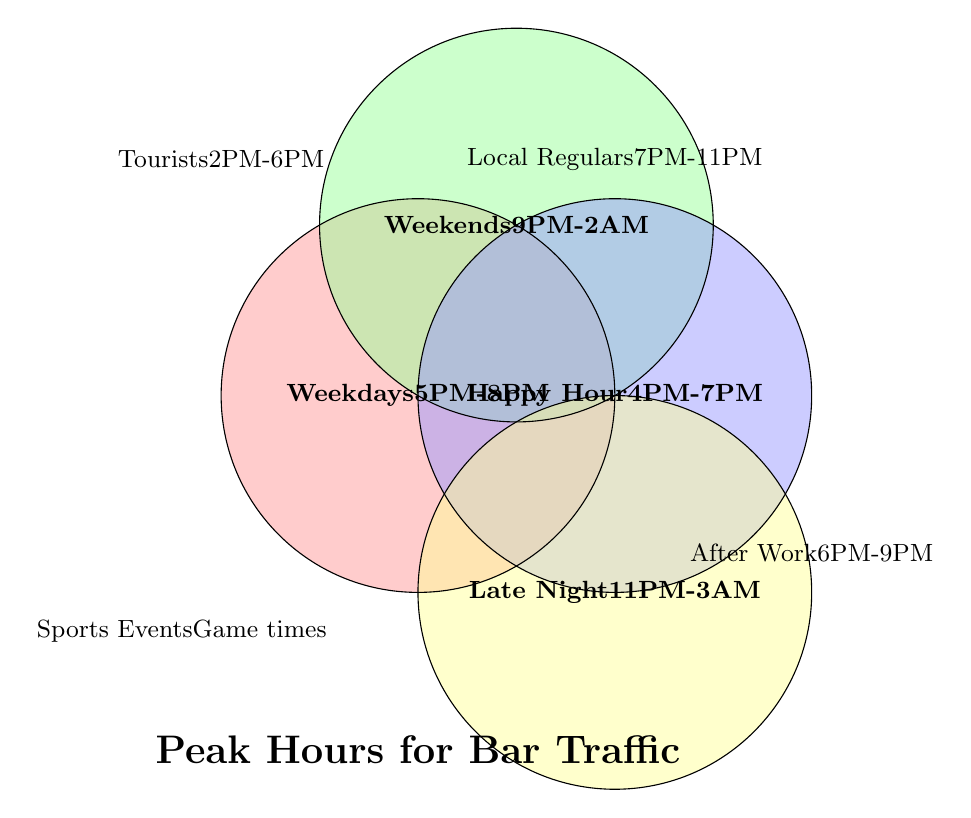What is the peak hour range for Weekdays? Locate the section labeled "Weekdays" in the Venn Diagram, which shows "5PM-8PM."
Answer: 5PM-8PM When do Tourists tend to visit the bar most frequently? Find the block labeled "Tourists," which shows "2PM-6PM."
Answer: 2PM-6PM Which group has a peak hour range overlapping with Happy Hour? Compare "Happy Hour" (4PM-7PM) with other groups. The After Work Crowd overlaps (6PM-9PM).
Answer: After Work Crowd What are the peak hours for the After Work Crowd? Find the block labeled "After Work Crowd," which shows "6PM-9PM."
Answer: 6PM-9PM Are the peak hours for Local Regulars completely within Late Night hours? Compare "Local Regulars" (7PM-11PM) with "Late Night" (11PM-3AM). The hours do not overlap completely; Local Regulars peak before Late Night starts.
Answer: No Which group has the latest peak hours? Identify the group with the latest ending time, "Late Night (11PM-3AM)."
Answer: Late Night What is the most crowded time range on Weekends? Find the section labeled "Weekends," which shows "9PM-2AM."
Answer: 9PM-2AM Do the peak hours for Sports Events overlap with any specific time range listed? "Sports Events" list "During game times," which is situational and hence may overlap with different times depending on when games occur.
Answer: Varies Is Happy Hour included in the peak hours for Weekdays? Compare "Happy Hour" (4PM-7PM) with "Weekdays" (5PM-8PM). Only the hours from 5PM-7PM overlap.
Answer: Partially 